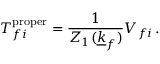Convert formula to latex. <formula><loc_0><loc_0><loc_500><loc_500>T _ { f i } ^ { p r o p e r } = \frac { 1 } { Z _ { 1 } ( \underline { k } _ { f } ) } V _ { f i } \, .</formula> 